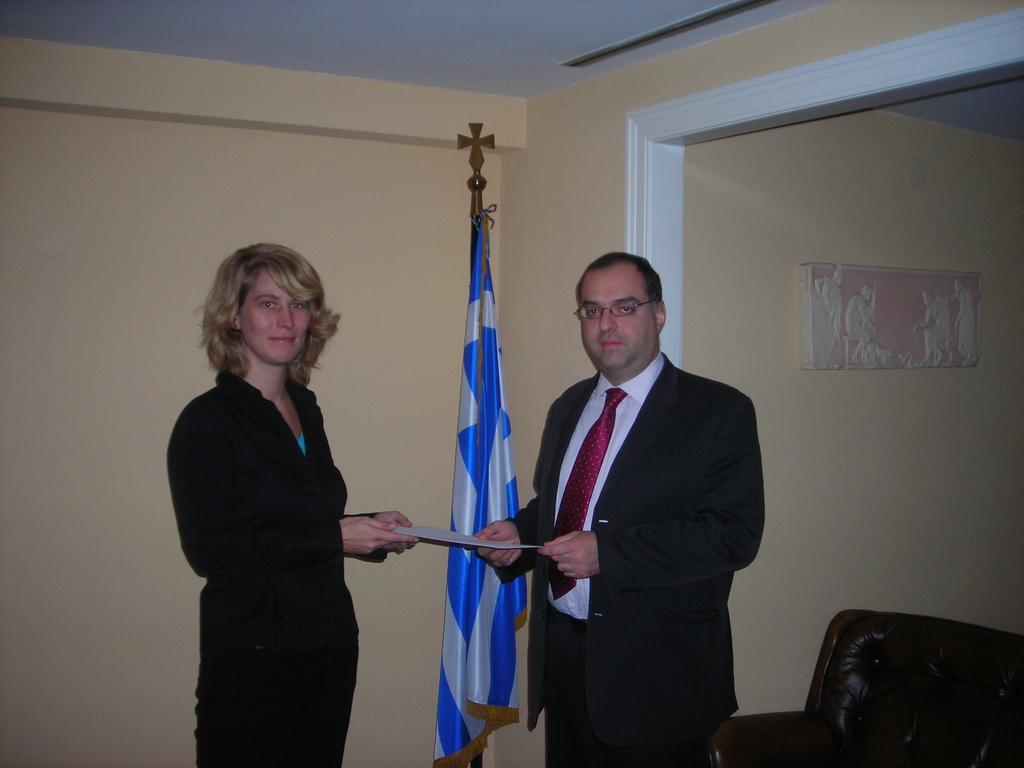Can you describe this image briefly? A man is giving certificate to a woman. Behind them there is a wall and flag. 